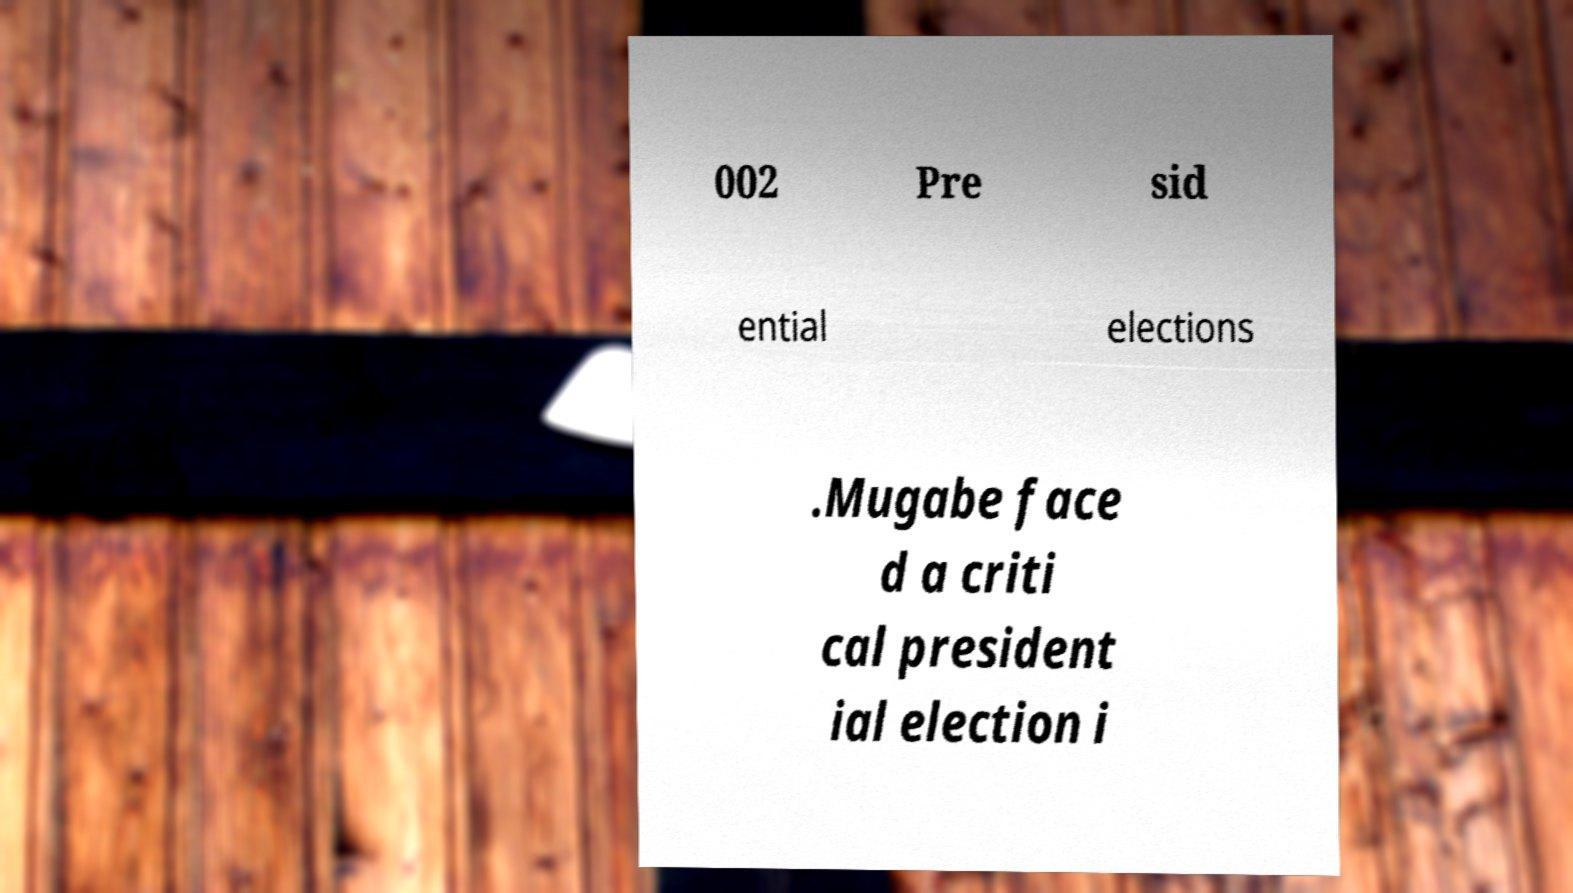Can you accurately transcribe the text from the provided image for me? 002 Pre sid ential elections .Mugabe face d a criti cal president ial election i 